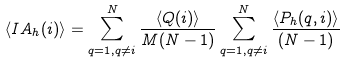<formula> <loc_0><loc_0><loc_500><loc_500>\left < I A _ { h } ( i ) \right > = \sum _ { q = 1 , q \neq i } ^ { N } \frac { \left < Q ( i ) \right > } { M ( N - 1 ) } \sum _ { q = 1 , q \neq i } ^ { N } \frac { \left < P _ { h } ( q , i ) \right > } { ( N - 1 ) }</formula> 